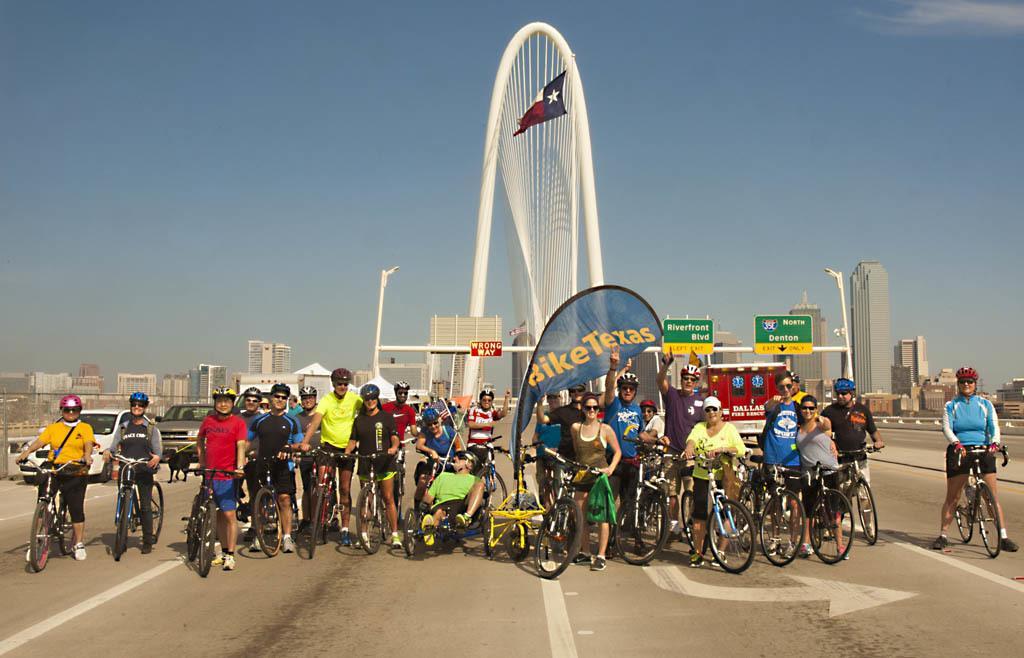Please provide a concise description of this image. In this image there are group of people standing on the floor by holding the cycles and wearing the helmets. Behind them there is an arch to which there are boards. On the right side there is a road on which there is a vehicle in the background. At the top there is a flag. Behind the flag we can see there are so many buildings in the background. At the top there is the sky. On the road there is an arrow symbol. 